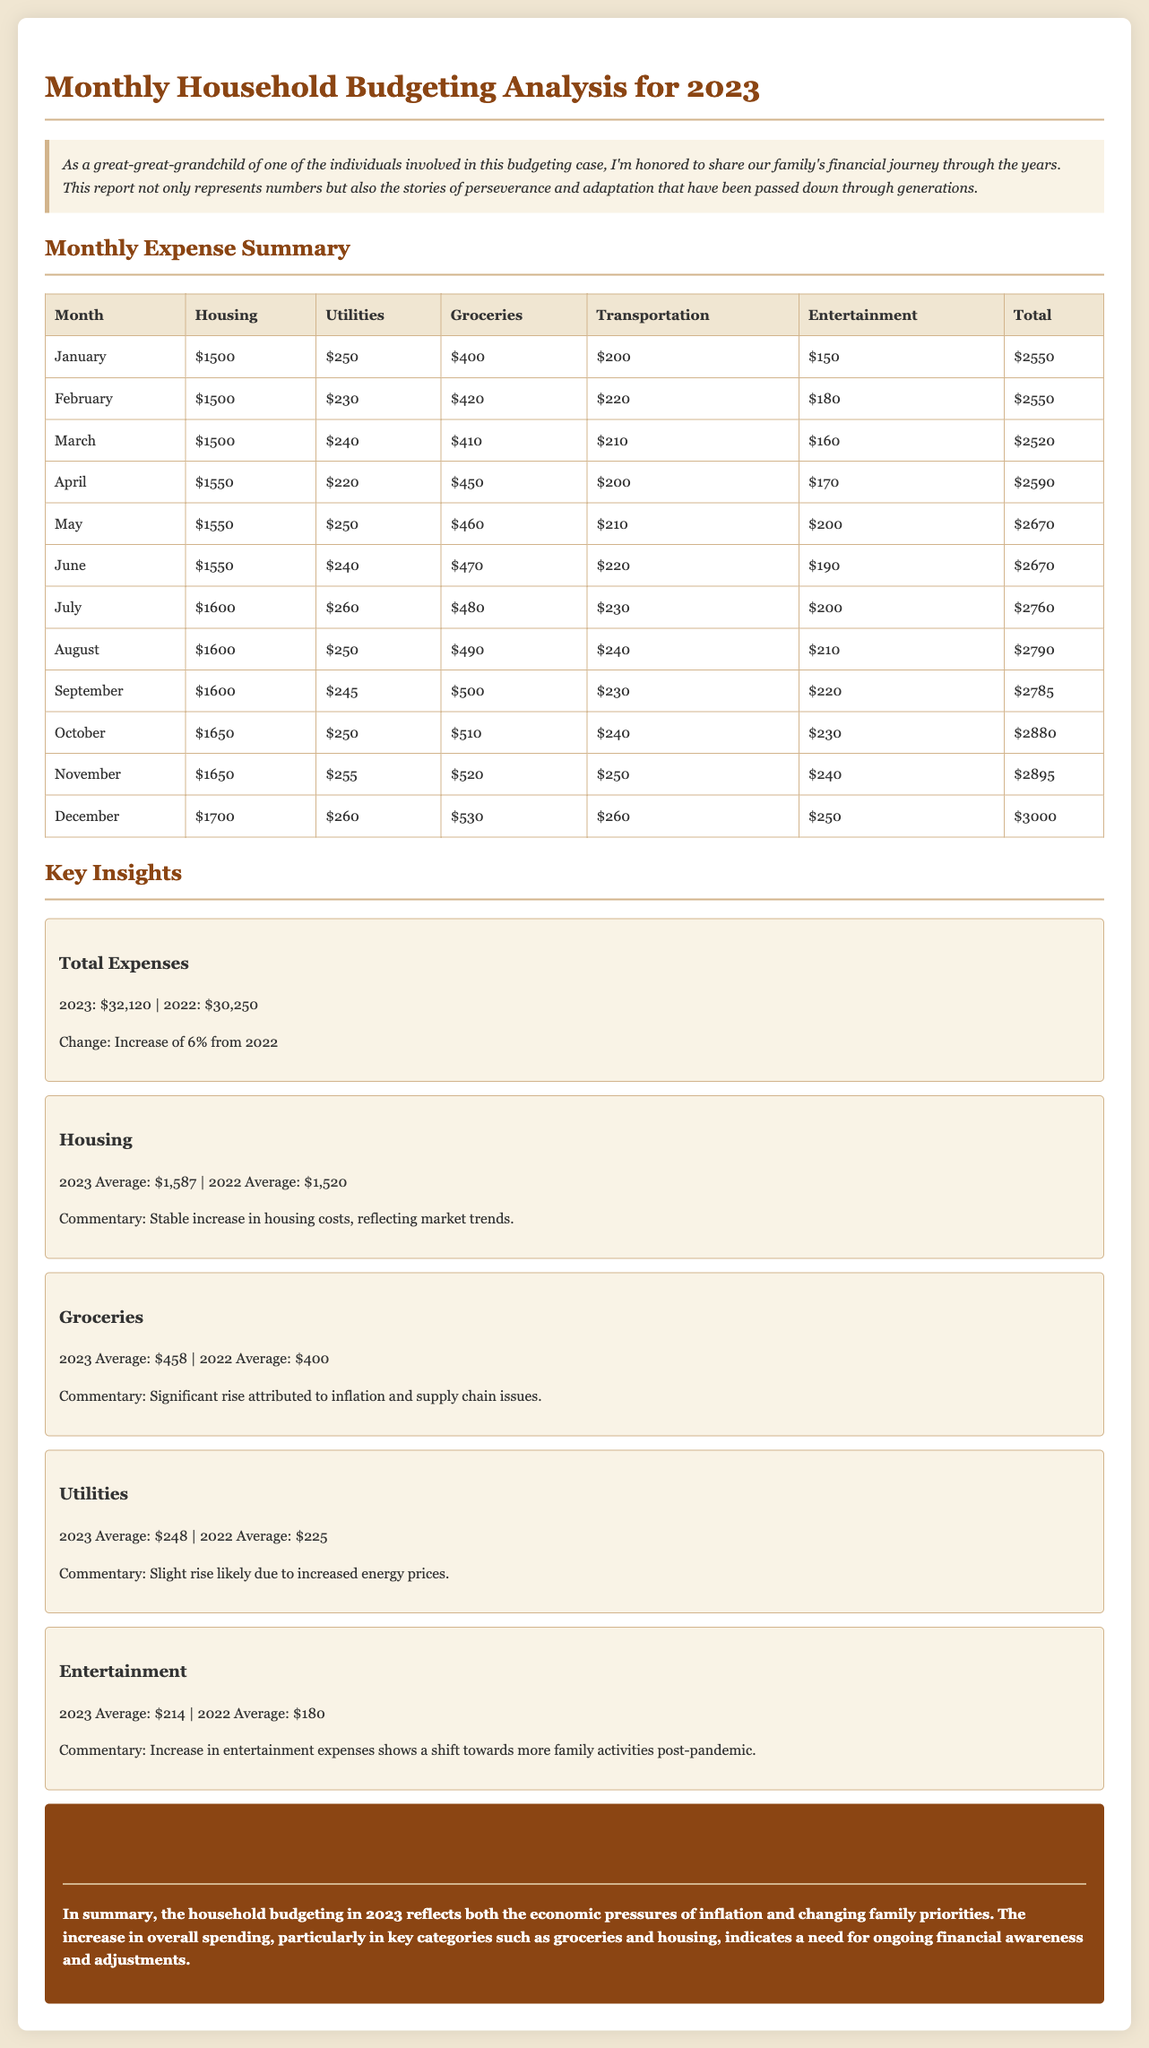What was the total expense for 2023? The total expense is summarized in the key insights section of the document.
Answer: $32,120 What was the average housing cost in 2023? The average housing cost is calculated and presented in the key insights section.
Answer: $1,587 What category saw a significant rise due to inflation? The commentary in the key insights explains the reason for this increase in a specific category.
Answer: Groceries What is the percentage increase in total expenses from 2022 to 2023? The change in total expenses is stated in the key insights section.
Answer: 6% Which month had the highest total expenses? The monthly expense summary table shows the total expenses for each month, which can be compared.
Answer: December What was the average utility cost in 2022? The average utility cost is referenced in the key insights comparing both years.
Answer: $225 What does the increase in entertainment expenses indicate? The commentary in the insights section reflects on the new spending habits post-pandemic.
Answer: More family activities What was the average transportation expense for July? This value can be found in the monthly summary table for that specific month.
Answer: $230 What was the total increase in housing costs from 2022 to 2023? This change is detailed in the key insights comparing both years; by subtraction we find the difference.
Answer: $67 